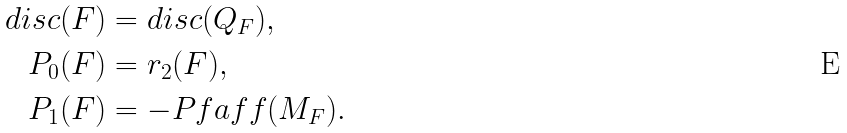Convert formula to latex. <formula><loc_0><loc_0><loc_500><loc_500>d i s c ( F ) & = d i s c ( Q _ { F } ) , \\ P _ { 0 } ( F ) & = r _ { 2 } ( F ) , \\ P _ { 1 } ( F ) & = - P f a f f ( M _ { F } ) .</formula> 